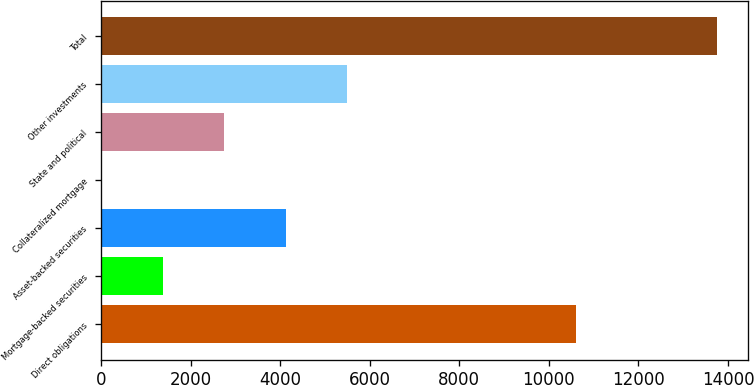Convert chart to OTSL. <chart><loc_0><loc_0><loc_500><loc_500><bar_chart><fcel>Direct obligations<fcel>Mortgage-backed securities<fcel>Asset-backed securities<fcel>Collateralized mortgage<fcel>State and political<fcel>Other investments<fcel>Total<nl><fcel>10615<fcel>1375.9<fcel>4125.7<fcel>1<fcel>2750.8<fcel>5500.6<fcel>13750<nl></chart> 